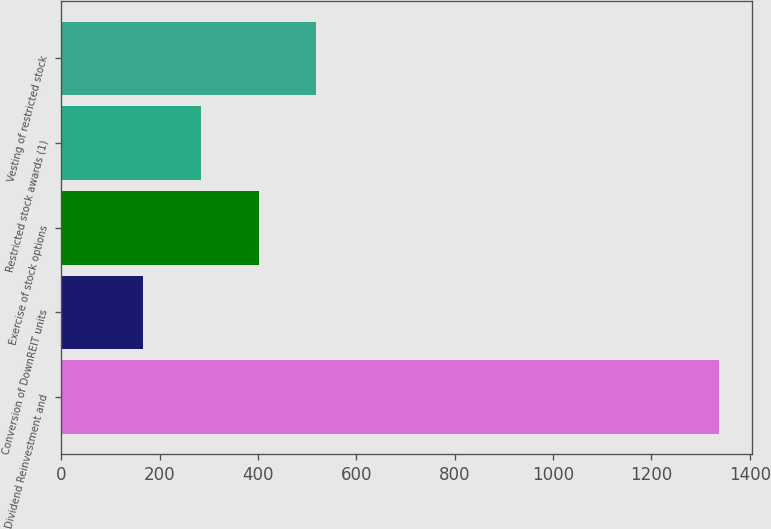Convert chart. <chart><loc_0><loc_0><loc_500><loc_500><bar_chart><fcel>Dividend Reinvestment and<fcel>Conversion of DownREIT units<fcel>Exercise of stock options<fcel>Restricted stock awards (1)<fcel>Vesting of restricted stock<nl><fcel>1338<fcel>167<fcel>401.2<fcel>284.1<fcel>518.3<nl></chart> 